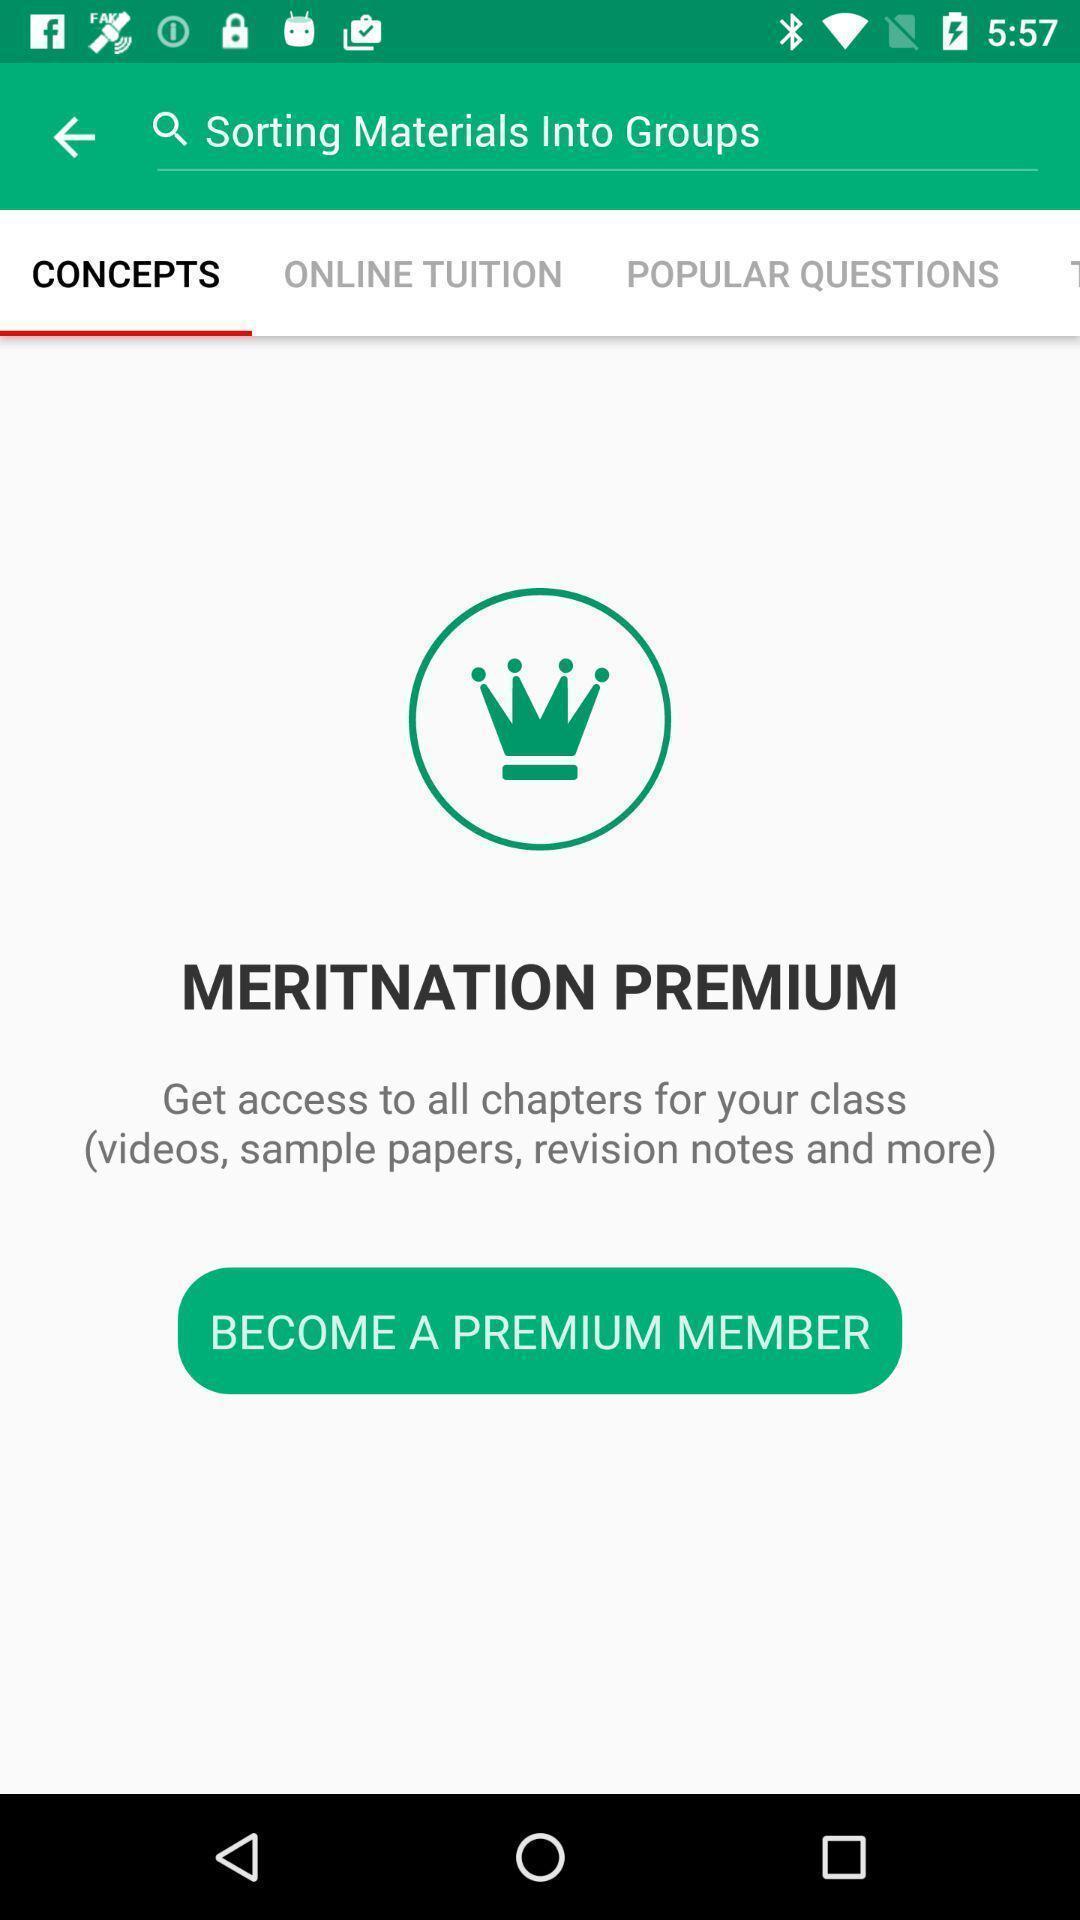Please provide a description for this image. Page displaying to access a premium membership. 